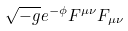<formula> <loc_0><loc_0><loc_500><loc_500>\sqrt { - g } e ^ { - \phi } F ^ { \mu \nu } F _ { \mu \nu }</formula> 